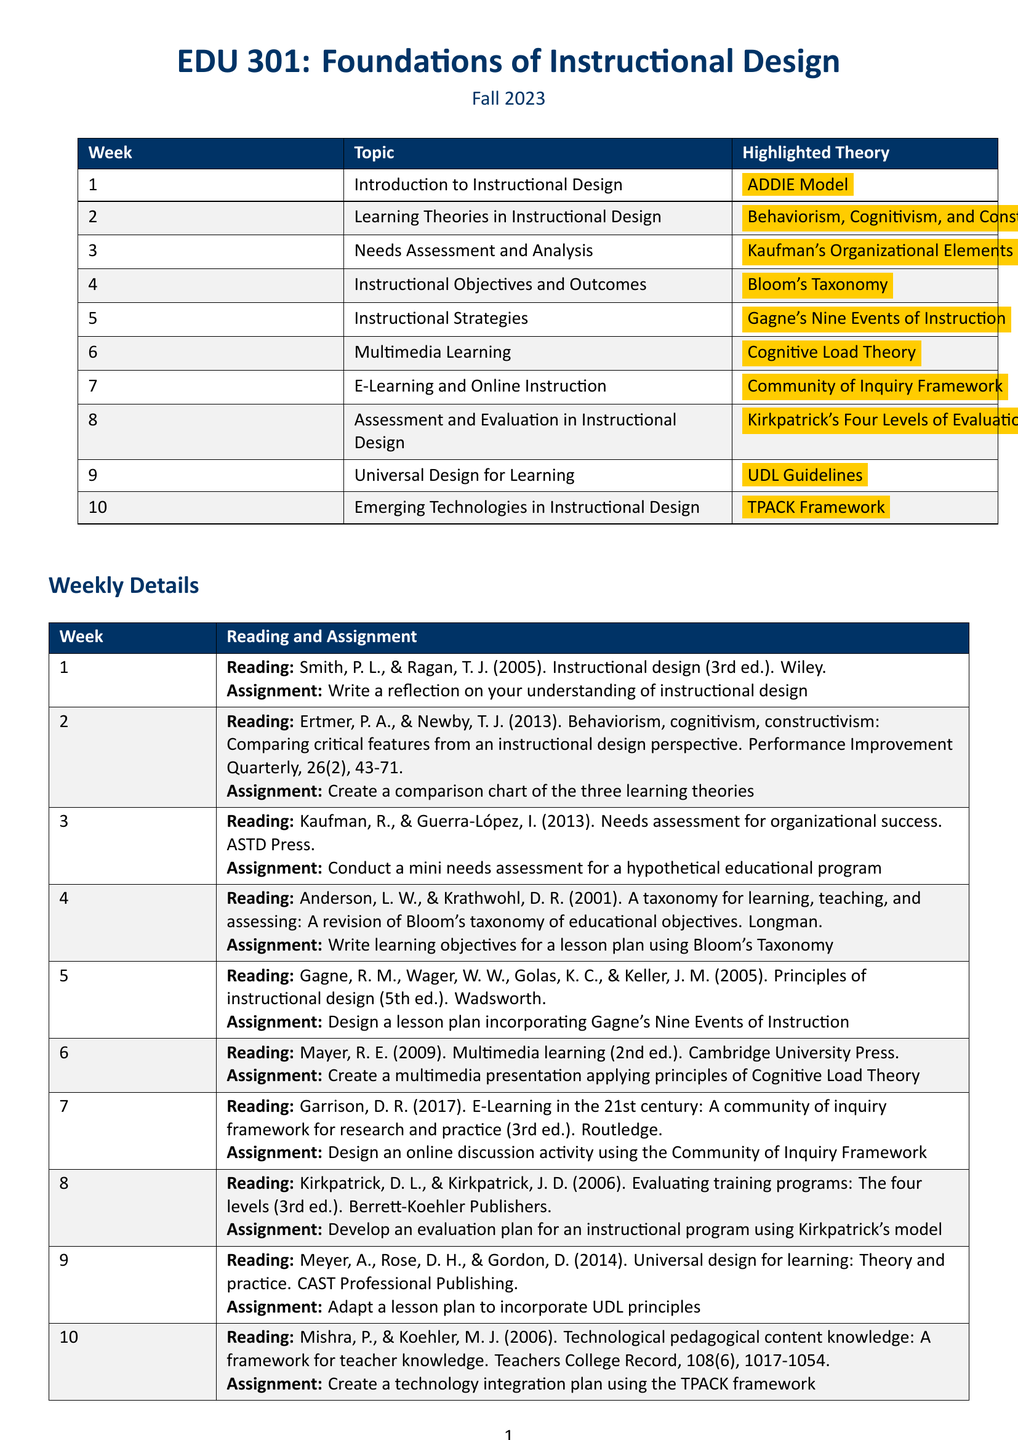What is the course name? The course name is explicitly stated at the beginning of the document.
Answer: EDU 301: Foundations of Instructional Design In which semester is this course offered? The semester is mentioned in the header of the document.
Answer: Fall 2023 What is the highlighted theory in week 4? The highlighted theory for week 4 can be found in the schedule table.
Answer: Bloom's Taxonomy How many weeks are covered in this schedule? The total number of weeks is given in the weekly schedule section of the document.
Answer: 10 What is the assignment for week 7? The assignment can be identified under week 7 in the weekly details section.
Answer: Design an online discussion activity using the Community of Inquiry Framework What theory is associated with the topic "Multimedia Learning"? The theory linked to the Multimedia Learning topic is indicated in the weekly schedule.
Answer: Cognitive Load Theory Which reading is assigned for week 2? The assigned reading for week 2 is specified clearly in the document.
Answer: Ertmer, P. A., & Newby, T. J. (2013). Behaviorism, cognitivism, constructivism: Comparing critical features from an instructional design perspective What type of document is this? The structure and content indicate the nature of the document as a course schedule.
Answer: Course schedule 